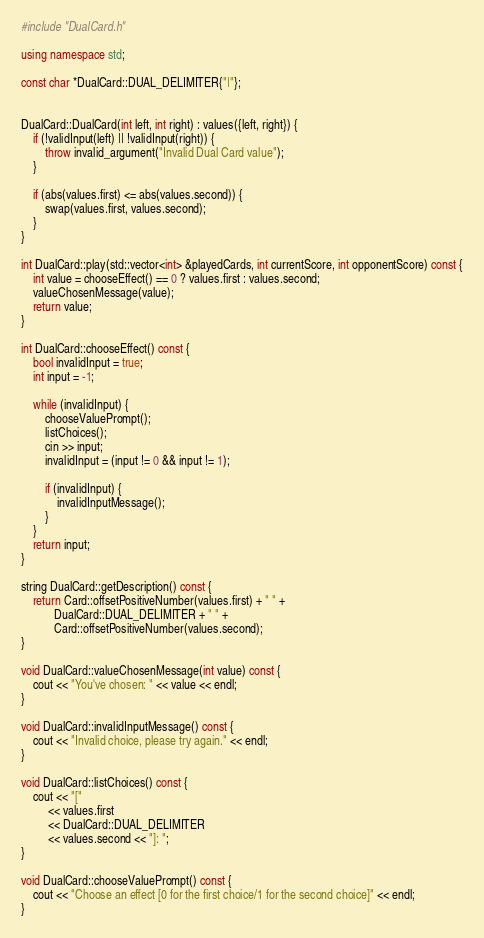<code> <loc_0><loc_0><loc_500><loc_500><_C++_>#include "DualCard.h"

using namespace std;

const char *DualCard::DUAL_DELIMITER{"|"};


DualCard::DualCard(int left, int right) : values({left, right}) {
    if (!validInput(left) || !validInput(right)) {
        throw invalid_argument("Invalid Dual Card value");
    }

    if (abs(values.first) <= abs(values.second)) {
        swap(values.first, values.second);
    }
}

int DualCard::play(std::vector<int> &playedCards, int currentScore, int opponentScore) const {
    int value = chooseEffect() == 0 ? values.first : values.second;
    valueChosenMessage(value);
    return value;
}

int DualCard::chooseEffect() const {
    bool invalidInput = true;
    int input = -1;

    while (invalidInput) {
        chooseValuePrompt();
        listChoices();
        cin >> input;
        invalidInput = (input != 0 && input != 1);

        if (invalidInput) {
            invalidInputMessage();
        }
    }
    return input;
}

string DualCard::getDescription() const {
    return Card::offsetPositiveNumber(values.first) + " " +
           DualCard::DUAL_DELIMITER + " " +
           Card::offsetPositiveNumber(values.second);
}

void DualCard::valueChosenMessage(int value) const {
    cout << "You've chosen: " << value << endl;
}

void DualCard::invalidInputMessage() const {
    cout << "Invalid choice, please try again." << endl;
}

void DualCard::listChoices() const {
    cout << "["
         << values.first
         << DualCard::DUAL_DELIMITER
         << values.second << "]: ";
}

void DualCard::chooseValuePrompt() const {
    cout << "Choose an effect [0 for the first choice/1 for the second choice]" << endl;
}

</code> 